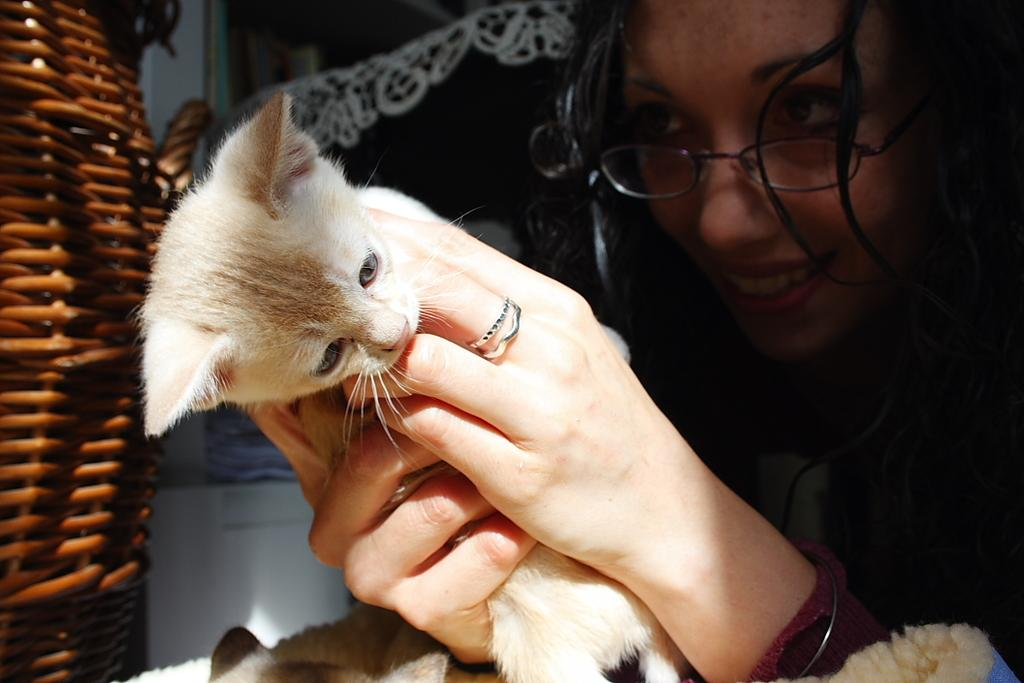Who is the main subject in the image? There is a woman in the image. What is the woman wearing? The woman is wearing spectacles. What is the woman holding in her hands? The woman is holding a cat in her hands. What can be seen in the background of the image? There are other objects in the background of the image. What type of jam is the beggar asking for in the image? There is no beggar or jam present in the image. How deep is the mine in the image? There is no mine present in the image. 